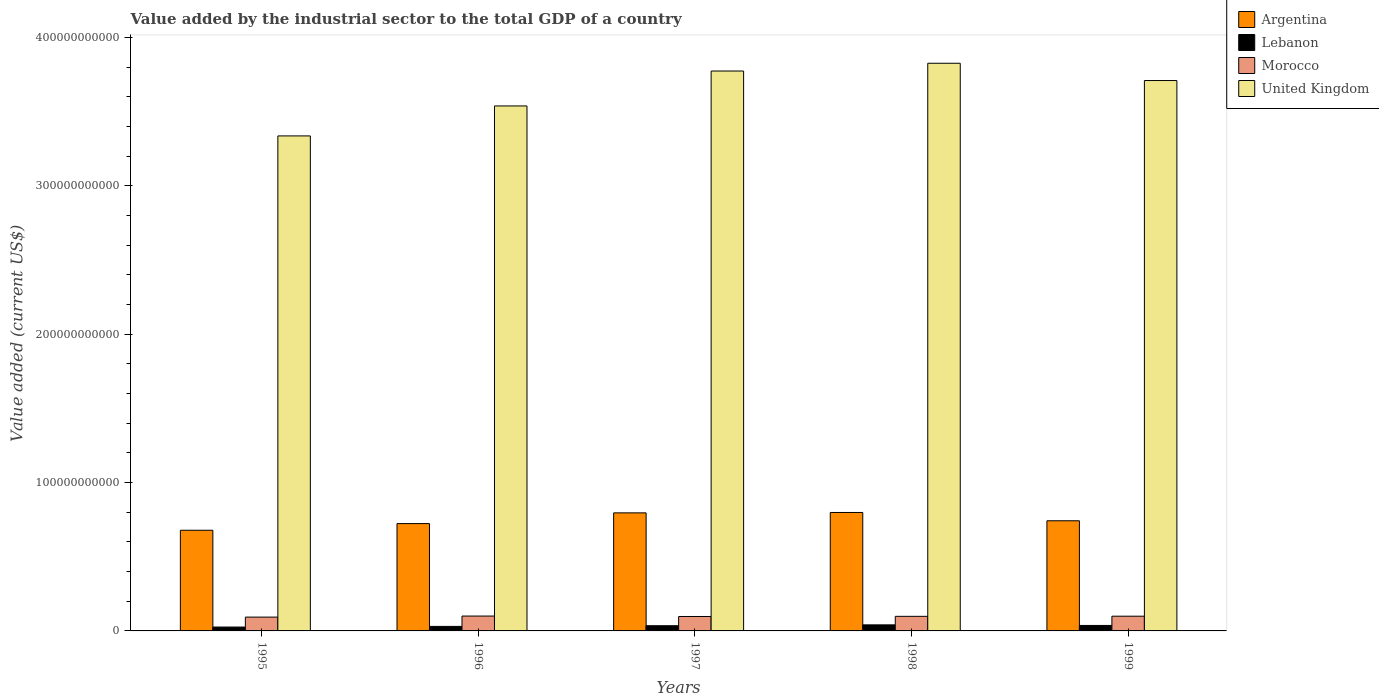How many different coloured bars are there?
Your response must be concise. 4. What is the value added by the industrial sector to the total GDP in Lebanon in 1998?
Provide a succinct answer. 4.08e+09. Across all years, what is the maximum value added by the industrial sector to the total GDP in Argentina?
Make the answer very short. 7.99e+1. Across all years, what is the minimum value added by the industrial sector to the total GDP in United Kingdom?
Your answer should be very brief. 3.34e+11. What is the total value added by the industrial sector to the total GDP in Lebanon in the graph?
Your answer should be very brief. 1.69e+1. What is the difference between the value added by the industrial sector to the total GDP in Argentina in 1997 and that in 1999?
Your answer should be very brief. 5.33e+09. What is the difference between the value added by the industrial sector to the total GDP in Morocco in 1999 and the value added by the industrial sector to the total GDP in Argentina in 1995?
Offer a very short reply. -5.79e+1. What is the average value added by the industrial sector to the total GDP in United Kingdom per year?
Your answer should be very brief. 3.64e+11. In the year 1997, what is the difference between the value added by the industrial sector to the total GDP in Argentina and value added by the industrial sector to the total GDP in Lebanon?
Your answer should be very brief. 7.61e+1. What is the ratio of the value added by the industrial sector to the total GDP in Lebanon in 1996 to that in 1997?
Keep it short and to the point. 0.87. Is the difference between the value added by the industrial sector to the total GDP in Argentina in 1996 and 1998 greater than the difference between the value added by the industrial sector to the total GDP in Lebanon in 1996 and 1998?
Provide a short and direct response. No. What is the difference between the highest and the second highest value added by the industrial sector to the total GDP in Lebanon?
Give a very brief answer. 3.93e+08. What is the difference between the highest and the lowest value added by the industrial sector to the total GDP in Argentina?
Your answer should be very brief. 1.20e+1. What does the 1st bar from the left in 1999 represents?
Provide a succinct answer. Argentina. What does the 1st bar from the right in 1998 represents?
Your response must be concise. United Kingdom. Is it the case that in every year, the sum of the value added by the industrial sector to the total GDP in United Kingdom and value added by the industrial sector to the total GDP in Argentina is greater than the value added by the industrial sector to the total GDP in Morocco?
Provide a succinct answer. Yes. What is the difference between two consecutive major ticks on the Y-axis?
Provide a succinct answer. 1.00e+11. Does the graph contain any zero values?
Your answer should be very brief. No. Does the graph contain grids?
Offer a terse response. No. Where does the legend appear in the graph?
Make the answer very short. Top right. How are the legend labels stacked?
Provide a short and direct response. Vertical. What is the title of the graph?
Offer a terse response. Value added by the industrial sector to the total GDP of a country. Does "High income: OECD" appear as one of the legend labels in the graph?
Offer a very short reply. No. What is the label or title of the Y-axis?
Your answer should be compact. Value added (current US$). What is the Value added (current US$) of Argentina in 1995?
Keep it short and to the point. 6.79e+1. What is the Value added (current US$) of Lebanon in 1995?
Your answer should be very brief. 2.61e+09. What is the Value added (current US$) of Morocco in 1995?
Offer a terse response. 9.32e+09. What is the Value added (current US$) of United Kingdom in 1995?
Your answer should be very brief. 3.34e+11. What is the Value added (current US$) of Argentina in 1996?
Provide a short and direct response. 7.24e+1. What is the Value added (current US$) of Lebanon in 1996?
Your response must be concise. 3.05e+09. What is the Value added (current US$) of Morocco in 1996?
Make the answer very short. 1.00e+1. What is the Value added (current US$) of United Kingdom in 1996?
Provide a short and direct response. 3.54e+11. What is the Value added (current US$) of Argentina in 1997?
Provide a succinct answer. 7.96e+1. What is the Value added (current US$) in Lebanon in 1997?
Keep it short and to the point. 3.51e+09. What is the Value added (current US$) in Morocco in 1997?
Offer a very short reply. 9.73e+09. What is the Value added (current US$) of United Kingdom in 1997?
Provide a succinct answer. 3.77e+11. What is the Value added (current US$) in Argentina in 1998?
Ensure brevity in your answer.  7.99e+1. What is the Value added (current US$) of Lebanon in 1998?
Your response must be concise. 4.08e+09. What is the Value added (current US$) in Morocco in 1998?
Give a very brief answer. 9.83e+09. What is the Value added (current US$) in United Kingdom in 1998?
Keep it short and to the point. 3.83e+11. What is the Value added (current US$) of Argentina in 1999?
Give a very brief answer. 7.43e+1. What is the Value added (current US$) of Lebanon in 1999?
Offer a very short reply. 3.69e+09. What is the Value added (current US$) of Morocco in 1999?
Give a very brief answer. 9.93e+09. What is the Value added (current US$) in United Kingdom in 1999?
Provide a succinct answer. 3.71e+11. Across all years, what is the maximum Value added (current US$) of Argentina?
Keep it short and to the point. 7.99e+1. Across all years, what is the maximum Value added (current US$) of Lebanon?
Give a very brief answer. 4.08e+09. Across all years, what is the maximum Value added (current US$) in Morocco?
Ensure brevity in your answer.  1.00e+1. Across all years, what is the maximum Value added (current US$) of United Kingdom?
Provide a short and direct response. 3.83e+11. Across all years, what is the minimum Value added (current US$) in Argentina?
Ensure brevity in your answer.  6.79e+1. Across all years, what is the minimum Value added (current US$) of Lebanon?
Make the answer very short. 2.61e+09. Across all years, what is the minimum Value added (current US$) of Morocco?
Keep it short and to the point. 9.32e+09. Across all years, what is the minimum Value added (current US$) of United Kingdom?
Your answer should be compact. 3.34e+11. What is the total Value added (current US$) in Argentina in the graph?
Offer a terse response. 3.74e+11. What is the total Value added (current US$) in Lebanon in the graph?
Your answer should be compact. 1.69e+1. What is the total Value added (current US$) in Morocco in the graph?
Keep it short and to the point. 4.88e+1. What is the total Value added (current US$) in United Kingdom in the graph?
Offer a terse response. 1.82e+12. What is the difference between the Value added (current US$) of Argentina in 1995 and that in 1996?
Make the answer very short. -4.51e+09. What is the difference between the Value added (current US$) of Lebanon in 1995 and that in 1996?
Your answer should be very brief. -4.48e+08. What is the difference between the Value added (current US$) of Morocco in 1995 and that in 1996?
Provide a short and direct response. -7.05e+08. What is the difference between the Value added (current US$) of United Kingdom in 1995 and that in 1996?
Provide a succinct answer. -2.02e+1. What is the difference between the Value added (current US$) of Argentina in 1995 and that in 1997?
Offer a very short reply. -1.17e+1. What is the difference between the Value added (current US$) of Lebanon in 1995 and that in 1997?
Provide a short and direct response. -9.03e+08. What is the difference between the Value added (current US$) of Morocco in 1995 and that in 1997?
Keep it short and to the point. -4.09e+08. What is the difference between the Value added (current US$) in United Kingdom in 1995 and that in 1997?
Give a very brief answer. -4.37e+1. What is the difference between the Value added (current US$) of Argentina in 1995 and that in 1998?
Your answer should be compact. -1.20e+1. What is the difference between the Value added (current US$) of Lebanon in 1995 and that in 1998?
Provide a succinct answer. -1.48e+09. What is the difference between the Value added (current US$) of Morocco in 1995 and that in 1998?
Provide a short and direct response. -5.13e+08. What is the difference between the Value added (current US$) in United Kingdom in 1995 and that in 1998?
Give a very brief answer. -4.90e+1. What is the difference between the Value added (current US$) of Argentina in 1995 and that in 1999?
Give a very brief answer. -6.40e+09. What is the difference between the Value added (current US$) in Lebanon in 1995 and that in 1999?
Your answer should be very brief. -1.09e+09. What is the difference between the Value added (current US$) of Morocco in 1995 and that in 1999?
Ensure brevity in your answer.  -6.14e+08. What is the difference between the Value added (current US$) of United Kingdom in 1995 and that in 1999?
Ensure brevity in your answer.  -3.73e+1. What is the difference between the Value added (current US$) of Argentina in 1996 and that in 1997?
Offer a terse response. -7.22e+09. What is the difference between the Value added (current US$) in Lebanon in 1996 and that in 1997?
Offer a terse response. -4.54e+08. What is the difference between the Value added (current US$) in Morocco in 1996 and that in 1997?
Ensure brevity in your answer.  2.96e+08. What is the difference between the Value added (current US$) of United Kingdom in 1996 and that in 1997?
Offer a terse response. -2.35e+1. What is the difference between the Value added (current US$) in Argentina in 1996 and that in 1998?
Offer a terse response. -7.48e+09. What is the difference between the Value added (current US$) of Lebanon in 1996 and that in 1998?
Offer a terse response. -1.03e+09. What is the difference between the Value added (current US$) in Morocco in 1996 and that in 1998?
Make the answer very short. 1.91e+08. What is the difference between the Value added (current US$) in United Kingdom in 1996 and that in 1998?
Your response must be concise. -2.88e+1. What is the difference between the Value added (current US$) of Argentina in 1996 and that in 1999?
Your response must be concise. -1.89e+09. What is the difference between the Value added (current US$) in Lebanon in 1996 and that in 1999?
Your answer should be compact. -6.38e+08. What is the difference between the Value added (current US$) of Morocco in 1996 and that in 1999?
Give a very brief answer. 9.06e+07. What is the difference between the Value added (current US$) in United Kingdom in 1996 and that in 1999?
Your response must be concise. -1.71e+1. What is the difference between the Value added (current US$) of Argentina in 1997 and that in 1998?
Your answer should be compact. -2.59e+08. What is the difference between the Value added (current US$) in Lebanon in 1997 and that in 1998?
Provide a short and direct response. -5.76e+08. What is the difference between the Value added (current US$) of Morocco in 1997 and that in 1998?
Provide a succinct answer. -1.05e+08. What is the difference between the Value added (current US$) in United Kingdom in 1997 and that in 1998?
Provide a short and direct response. -5.23e+09. What is the difference between the Value added (current US$) in Argentina in 1997 and that in 1999?
Provide a succinct answer. 5.33e+09. What is the difference between the Value added (current US$) of Lebanon in 1997 and that in 1999?
Provide a short and direct response. -1.84e+08. What is the difference between the Value added (current US$) of Morocco in 1997 and that in 1999?
Provide a short and direct response. -2.05e+08. What is the difference between the Value added (current US$) of United Kingdom in 1997 and that in 1999?
Your response must be concise. 6.41e+09. What is the difference between the Value added (current US$) of Argentina in 1998 and that in 1999?
Offer a terse response. 5.59e+09. What is the difference between the Value added (current US$) in Lebanon in 1998 and that in 1999?
Your response must be concise. 3.93e+08. What is the difference between the Value added (current US$) in Morocco in 1998 and that in 1999?
Make the answer very short. -1.01e+08. What is the difference between the Value added (current US$) in United Kingdom in 1998 and that in 1999?
Your answer should be very brief. 1.16e+1. What is the difference between the Value added (current US$) in Argentina in 1995 and the Value added (current US$) in Lebanon in 1996?
Keep it short and to the point. 6.48e+1. What is the difference between the Value added (current US$) in Argentina in 1995 and the Value added (current US$) in Morocco in 1996?
Your response must be concise. 5.78e+1. What is the difference between the Value added (current US$) in Argentina in 1995 and the Value added (current US$) in United Kingdom in 1996?
Your response must be concise. -2.86e+11. What is the difference between the Value added (current US$) in Lebanon in 1995 and the Value added (current US$) in Morocco in 1996?
Ensure brevity in your answer.  -7.42e+09. What is the difference between the Value added (current US$) in Lebanon in 1995 and the Value added (current US$) in United Kingdom in 1996?
Offer a very short reply. -3.51e+11. What is the difference between the Value added (current US$) in Morocco in 1995 and the Value added (current US$) in United Kingdom in 1996?
Your answer should be compact. -3.45e+11. What is the difference between the Value added (current US$) in Argentina in 1995 and the Value added (current US$) in Lebanon in 1997?
Provide a succinct answer. 6.44e+1. What is the difference between the Value added (current US$) in Argentina in 1995 and the Value added (current US$) in Morocco in 1997?
Offer a very short reply. 5.81e+1. What is the difference between the Value added (current US$) in Argentina in 1995 and the Value added (current US$) in United Kingdom in 1997?
Your response must be concise. -3.10e+11. What is the difference between the Value added (current US$) in Lebanon in 1995 and the Value added (current US$) in Morocco in 1997?
Provide a succinct answer. -7.12e+09. What is the difference between the Value added (current US$) of Lebanon in 1995 and the Value added (current US$) of United Kingdom in 1997?
Give a very brief answer. -3.75e+11. What is the difference between the Value added (current US$) in Morocco in 1995 and the Value added (current US$) in United Kingdom in 1997?
Provide a succinct answer. -3.68e+11. What is the difference between the Value added (current US$) in Argentina in 1995 and the Value added (current US$) in Lebanon in 1998?
Your answer should be compact. 6.38e+1. What is the difference between the Value added (current US$) of Argentina in 1995 and the Value added (current US$) of Morocco in 1998?
Your answer should be very brief. 5.80e+1. What is the difference between the Value added (current US$) of Argentina in 1995 and the Value added (current US$) of United Kingdom in 1998?
Offer a terse response. -3.15e+11. What is the difference between the Value added (current US$) of Lebanon in 1995 and the Value added (current US$) of Morocco in 1998?
Offer a terse response. -7.23e+09. What is the difference between the Value added (current US$) of Lebanon in 1995 and the Value added (current US$) of United Kingdom in 1998?
Keep it short and to the point. -3.80e+11. What is the difference between the Value added (current US$) of Morocco in 1995 and the Value added (current US$) of United Kingdom in 1998?
Provide a succinct answer. -3.73e+11. What is the difference between the Value added (current US$) of Argentina in 1995 and the Value added (current US$) of Lebanon in 1999?
Your answer should be very brief. 6.42e+1. What is the difference between the Value added (current US$) of Argentina in 1995 and the Value added (current US$) of Morocco in 1999?
Give a very brief answer. 5.79e+1. What is the difference between the Value added (current US$) in Argentina in 1995 and the Value added (current US$) in United Kingdom in 1999?
Keep it short and to the point. -3.03e+11. What is the difference between the Value added (current US$) in Lebanon in 1995 and the Value added (current US$) in Morocco in 1999?
Provide a short and direct response. -7.33e+09. What is the difference between the Value added (current US$) of Lebanon in 1995 and the Value added (current US$) of United Kingdom in 1999?
Provide a succinct answer. -3.68e+11. What is the difference between the Value added (current US$) in Morocco in 1995 and the Value added (current US$) in United Kingdom in 1999?
Offer a very short reply. -3.62e+11. What is the difference between the Value added (current US$) in Argentina in 1996 and the Value added (current US$) in Lebanon in 1997?
Keep it short and to the point. 6.89e+1. What is the difference between the Value added (current US$) of Argentina in 1996 and the Value added (current US$) of Morocco in 1997?
Your response must be concise. 6.26e+1. What is the difference between the Value added (current US$) in Argentina in 1996 and the Value added (current US$) in United Kingdom in 1997?
Your answer should be compact. -3.05e+11. What is the difference between the Value added (current US$) in Lebanon in 1996 and the Value added (current US$) in Morocco in 1997?
Provide a succinct answer. -6.67e+09. What is the difference between the Value added (current US$) in Lebanon in 1996 and the Value added (current US$) in United Kingdom in 1997?
Offer a terse response. -3.74e+11. What is the difference between the Value added (current US$) in Morocco in 1996 and the Value added (current US$) in United Kingdom in 1997?
Your answer should be very brief. -3.67e+11. What is the difference between the Value added (current US$) in Argentina in 1996 and the Value added (current US$) in Lebanon in 1998?
Your answer should be compact. 6.83e+1. What is the difference between the Value added (current US$) in Argentina in 1996 and the Value added (current US$) in Morocco in 1998?
Keep it short and to the point. 6.25e+1. What is the difference between the Value added (current US$) in Argentina in 1996 and the Value added (current US$) in United Kingdom in 1998?
Give a very brief answer. -3.10e+11. What is the difference between the Value added (current US$) in Lebanon in 1996 and the Value added (current US$) in Morocco in 1998?
Your answer should be compact. -6.78e+09. What is the difference between the Value added (current US$) in Lebanon in 1996 and the Value added (current US$) in United Kingdom in 1998?
Your response must be concise. -3.80e+11. What is the difference between the Value added (current US$) of Morocco in 1996 and the Value added (current US$) of United Kingdom in 1998?
Provide a short and direct response. -3.73e+11. What is the difference between the Value added (current US$) in Argentina in 1996 and the Value added (current US$) in Lebanon in 1999?
Offer a very short reply. 6.87e+1. What is the difference between the Value added (current US$) of Argentina in 1996 and the Value added (current US$) of Morocco in 1999?
Offer a terse response. 6.24e+1. What is the difference between the Value added (current US$) in Argentina in 1996 and the Value added (current US$) in United Kingdom in 1999?
Offer a terse response. -2.99e+11. What is the difference between the Value added (current US$) of Lebanon in 1996 and the Value added (current US$) of Morocco in 1999?
Offer a very short reply. -6.88e+09. What is the difference between the Value added (current US$) in Lebanon in 1996 and the Value added (current US$) in United Kingdom in 1999?
Your response must be concise. -3.68e+11. What is the difference between the Value added (current US$) in Morocco in 1996 and the Value added (current US$) in United Kingdom in 1999?
Your response must be concise. -3.61e+11. What is the difference between the Value added (current US$) of Argentina in 1997 and the Value added (current US$) of Lebanon in 1998?
Your response must be concise. 7.55e+1. What is the difference between the Value added (current US$) in Argentina in 1997 and the Value added (current US$) in Morocco in 1998?
Your answer should be very brief. 6.98e+1. What is the difference between the Value added (current US$) in Argentina in 1997 and the Value added (current US$) in United Kingdom in 1998?
Offer a very short reply. -3.03e+11. What is the difference between the Value added (current US$) of Lebanon in 1997 and the Value added (current US$) of Morocco in 1998?
Give a very brief answer. -6.32e+09. What is the difference between the Value added (current US$) in Lebanon in 1997 and the Value added (current US$) in United Kingdom in 1998?
Give a very brief answer. -3.79e+11. What is the difference between the Value added (current US$) in Morocco in 1997 and the Value added (current US$) in United Kingdom in 1998?
Offer a terse response. -3.73e+11. What is the difference between the Value added (current US$) in Argentina in 1997 and the Value added (current US$) in Lebanon in 1999?
Make the answer very short. 7.59e+1. What is the difference between the Value added (current US$) in Argentina in 1997 and the Value added (current US$) in Morocco in 1999?
Ensure brevity in your answer.  6.97e+1. What is the difference between the Value added (current US$) of Argentina in 1997 and the Value added (current US$) of United Kingdom in 1999?
Your response must be concise. -2.91e+11. What is the difference between the Value added (current US$) in Lebanon in 1997 and the Value added (current US$) in Morocco in 1999?
Keep it short and to the point. -6.42e+09. What is the difference between the Value added (current US$) of Lebanon in 1997 and the Value added (current US$) of United Kingdom in 1999?
Give a very brief answer. -3.68e+11. What is the difference between the Value added (current US$) in Morocco in 1997 and the Value added (current US$) in United Kingdom in 1999?
Make the answer very short. -3.61e+11. What is the difference between the Value added (current US$) in Argentina in 1998 and the Value added (current US$) in Lebanon in 1999?
Give a very brief answer. 7.62e+1. What is the difference between the Value added (current US$) in Argentina in 1998 and the Value added (current US$) in Morocco in 1999?
Provide a short and direct response. 6.99e+1. What is the difference between the Value added (current US$) in Argentina in 1998 and the Value added (current US$) in United Kingdom in 1999?
Provide a short and direct response. -2.91e+11. What is the difference between the Value added (current US$) in Lebanon in 1998 and the Value added (current US$) in Morocco in 1999?
Provide a short and direct response. -5.85e+09. What is the difference between the Value added (current US$) of Lebanon in 1998 and the Value added (current US$) of United Kingdom in 1999?
Make the answer very short. -3.67e+11. What is the difference between the Value added (current US$) in Morocco in 1998 and the Value added (current US$) in United Kingdom in 1999?
Offer a very short reply. -3.61e+11. What is the average Value added (current US$) in Argentina per year?
Make the answer very short. 7.48e+1. What is the average Value added (current US$) in Lebanon per year?
Make the answer very short. 3.39e+09. What is the average Value added (current US$) of Morocco per year?
Give a very brief answer. 9.77e+09. What is the average Value added (current US$) of United Kingdom per year?
Keep it short and to the point. 3.64e+11. In the year 1995, what is the difference between the Value added (current US$) in Argentina and Value added (current US$) in Lebanon?
Your answer should be very brief. 6.53e+1. In the year 1995, what is the difference between the Value added (current US$) of Argentina and Value added (current US$) of Morocco?
Offer a terse response. 5.85e+1. In the year 1995, what is the difference between the Value added (current US$) in Argentina and Value added (current US$) in United Kingdom?
Provide a succinct answer. -2.66e+11. In the year 1995, what is the difference between the Value added (current US$) in Lebanon and Value added (current US$) in Morocco?
Your answer should be very brief. -6.71e+09. In the year 1995, what is the difference between the Value added (current US$) of Lebanon and Value added (current US$) of United Kingdom?
Your answer should be very brief. -3.31e+11. In the year 1995, what is the difference between the Value added (current US$) in Morocco and Value added (current US$) in United Kingdom?
Provide a succinct answer. -3.24e+11. In the year 1996, what is the difference between the Value added (current US$) of Argentina and Value added (current US$) of Lebanon?
Your answer should be very brief. 6.93e+1. In the year 1996, what is the difference between the Value added (current US$) in Argentina and Value added (current US$) in Morocco?
Offer a very short reply. 6.23e+1. In the year 1996, what is the difference between the Value added (current US$) of Argentina and Value added (current US$) of United Kingdom?
Provide a succinct answer. -2.82e+11. In the year 1996, what is the difference between the Value added (current US$) of Lebanon and Value added (current US$) of Morocco?
Offer a terse response. -6.97e+09. In the year 1996, what is the difference between the Value added (current US$) of Lebanon and Value added (current US$) of United Kingdom?
Provide a succinct answer. -3.51e+11. In the year 1996, what is the difference between the Value added (current US$) of Morocco and Value added (current US$) of United Kingdom?
Give a very brief answer. -3.44e+11. In the year 1997, what is the difference between the Value added (current US$) in Argentina and Value added (current US$) in Lebanon?
Keep it short and to the point. 7.61e+1. In the year 1997, what is the difference between the Value added (current US$) in Argentina and Value added (current US$) in Morocco?
Ensure brevity in your answer.  6.99e+1. In the year 1997, what is the difference between the Value added (current US$) in Argentina and Value added (current US$) in United Kingdom?
Offer a terse response. -2.98e+11. In the year 1997, what is the difference between the Value added (current US$) in Lebanon and Value added (current US$) in Morocco?
Make the answer very short. -6.22e+09. In the year 1997, what is the difference between the Value added (current US$) of Lebanon and Value added (current US$) of United Kingdom?
Provide a short and direct response. -3.74e+11. In the year 1997, what is the difference between the Value added (current US$) of Morocco and Value added (current US$) of United Kingdom?
Make the answer very short. -3.68e+11. In the year 1998, what is the difference between the Value added (current US$) of Argentina and Value added (current US$) of Lebanon?
Make the answer very short. 7.58e+1. In the year 1998, what is the difference between the Value added (current US$) of Argentina and Value added (current US$) of Morocco?
Keep it short and to the point. 7.00e+1. In the year 1998, what is the difference between the Value added (current US$) of Argentina and Value added (current US$) of United Kingdom?
Offer a terse response. -3.03e+11. In the year 1998, what is the difference between the Value added (current US$) in Lebanon and Value added (current US$) in Morocco?
Your response must be concise. -5.75e+09. In the year 1998, what is the difference between the Value added (current US$) in Lebanon and Value added (current US$) in United Kingdom?
Keep it short and to the point. -3.79e+11. In the year 1998, what is the difference between the Value added (current US$) in Morocco and Value added (current US$) in United Kingdom?
Offer a very short reply. -3.73e+11. In the year 1999, what is the difference between the Value added (current US$) in Argentina and Value added (current US$) in Lebanon?
Provide a succinct answer. 7.06e+1. In the year 1999, what is the difference between the Value added (current US$) in Argentina and Value added (current US$) in Morocco?
Ensure brevity in your answer.  6.43e+1. In the year 1999, what is the difference between the Value added (current US$) of Argentina and Value added (current US$) of United Kingdom?
Make the answer very short. -2.97e+11. In the year 1999, what is the difference between the Value added (current US$) of Lebanon and Value added (current US$) of Morocco?
Offer a very short reply. -6.24e+09. In the year 1999, what is the difference between the Value added (current US$) of Lebanon and Value added (current US$) of United Kingdom?
Your answer should be compact. -3.67e+11. In the year 1999, what is the difference between the Value added (current US$) in Morocco and Value added (current US$) in United Kingdom?
Offer a very short reply. -3.61e+11. What is the ratio of the Value added (current US$) of Argentina in 1995 to that in 1996?
Your answer should be compact. 0.94. What is the ratio of the Value added (current US$) in Lebanon in 1995 to that in 1996?
Ensure brevity in your answer.  0.85. What is the ratio of the Value added (current US$) in Morocco in 1995 to that in 1996?
Provide a succinct answer. 0.93. What is the ratio of the Value added (current US$) in United Kingdom in 1995 to that in 1996?
Make the answer very short. 0.94. What is the ratio of the Value added (current US$) in Argentina in 1995 to that in 1997?
Offer a very short reply. 0.85. What is the ratio of the Value added (current US$) in Lebanon in 1995 to that in 1997?
Provide a short and direct response. 0.74. What is the ratio of the Value added (current US$) in Morocco in 1995 to that in 1997?
Offer a terse response. 0.96. What is the ratio of the Value added (current US$) of United Kingdom in 1995 to that in 1997?
Provide a short and direct response. 0.88. What is the ratio of the Value added (current US$) of Argentina in 1995 to that in 1998?
Provide a short and direct response. 0.85. What is the ratio of the Value added (current US$) of Lebanon in 1995 to that in 1998?
Give a very brief answer. 0.64. What is the ratio of the Value added (current US$) in Morocco in 1995 to that in 1998?
Provide a short and direct response. 0.95. What is the ratio of the Value added (current US$) in United Kingdom in 1995 to that in 1998?
Ensure brevity in your answer.  0.87. What is the ratio of the Value added (current US$) in Argentina in 1995 to that in 1999?
Make the answer very short. 0.91. What is the ratio of the Value added (current US$) of Lebanon in 1995 to that in 1999?
Offer a terse response. 0.71. What is the ratio of the Value added (current US$) in Morocco in 1995 to that in 1999?
Provide a short and direct response. 0.94. What is the ratio of the Value added (current US$) of United Kingdom in 1995 to that in 1999?
Offer a very short reply. 0.9. What is the ratio of the Value added (current US$) in Argentina in 1996 to that in 1997?
Give a very brief answer. 0.91. What is the ratio of the Value added (current US$) of Lebanon in 1996 to that in 1997?
Your answer should be compact. 0.87. What is the ratio of the Value added (current US$) of Morocco in 1996 to that in 1997?
Your response must be concise. 1.03. What is the ratio of the Value added (current US$) in United Kingdom in 1996 to that in 1997?
Ensure brevity in your answer.  0.94. What is the ratio of the Value added (current US$) of Argentina in 1996 to that in 1998?
Your response must be concise. 0.91. What is the ratio of the Value added (current US$) in Lebanon in 1996 to that in 1998?
Provide a short and direct response. 0.75. What is the ratio of the Value added (current US$) in Morocco in 1996 to that in 1998?
Your answer should be compact. 1.02. What is the ratio of the Value added (current US$) of United Kingdom in 1996 to that in 1998?
Offer a terse response. 0.92. What is the ratio of the Value added (current US$) of Argentina in 1996 to that in 1999?
Keep it short and to the point. 0.97. What is the ratio of the Value added (current US$) of Lebanon in 1996 to that in 1999?
Your response must be concise. 0.83. What is the ratio of the Value added (current US$) of Morocco in 1996 to that in 1999?
Provide a succinct answer. 1.01. What is the ratio of the Value added (current US$) of United Kingdom in 1996 to that in 1999?
Ensure brevity in your answer.  0.95. What is the ratio of the Value added (current US$) in Argentina in 1997 to that in 1998?
Your answer should be very brief. 1. What is the ratio of the Value added (current US$) of Lebanon in 1997 to that in 1998?
Ensure brevity in your answer.  0.86. What is the ratio of the Value added (current US$) in Morocco in 1997 to that in 1998?
Offer a very short reply. 0.99. What is the ratio of the Value added (current US$) of United Kingdom in 1997 to that in 1998?
Your answer should be very brief. 0.99. What is the ratio of the Value added (current US$) in Argentina in 1997 to that in 1999?
Your answer should be compact. 1.07. What is the ratio of the Value added (current US$) of Lebanon in 1997 to that in 1999?
Give a very brief answer. 0.95. What is the ratio of the Value added (current US$) in Morocco in 1997 to that in 1999?
Your response must be concise. 0.98. What is the ratio of the Value added (current US$) of United Kingdom in 1997 to that in 1999?
Keep it short and to the point. 1.02. What is the ratio of the Value added (current US$) in Argentina in 1998 to that in 1999?
Provide a short and direct response. 1.08. What is the ratio of the Value added (current US$) of Lebanon in 1998 to that in 1999?
Your answer should be compact. 1.11. What is the ratio of the Value added (current US$) of Morocco in 1998 to that in 1999?
Your response must be concise. 0.99. What is the ratio of the Value added (current US$) in United Kingdom in 1998 to that in 1999?
Your answer should be compact. 1.03. What is the difference between the highest and the second highest Value added (current US$) of Argentina?
Keep it short and to the point. 2.59e+08. What is the difference between the highest and the second highest Value added (current US$) in Lebanon?
Make the answer very short. 3.93e+08. What is the difference between the highest and the second highest Value added (current US$) of Morocco?
Offer a very short reply. 9.06e+07. What is the difference between the highest and the second highest Value added (current US$) of United Kingdom?
Offer a very short reply. 5.23e+09. What is the difference between the highest and the lowest Value added (current US$) of Argentina?
Offer a terse response. 1.20e+1. What is the difference between the highest and the lowest Value added (current US$) in Lebanon?
Make the answer very short. 1.48e+09. What is the difference between the highest and the lowest Value added (current US$) of Morocco?
Provide a succinct answer. 7.05e+08. What is the difference between the highest and the lowest Value added (current US$) of United Kingdom?
Your answer should be compact. 4.90e+1. 